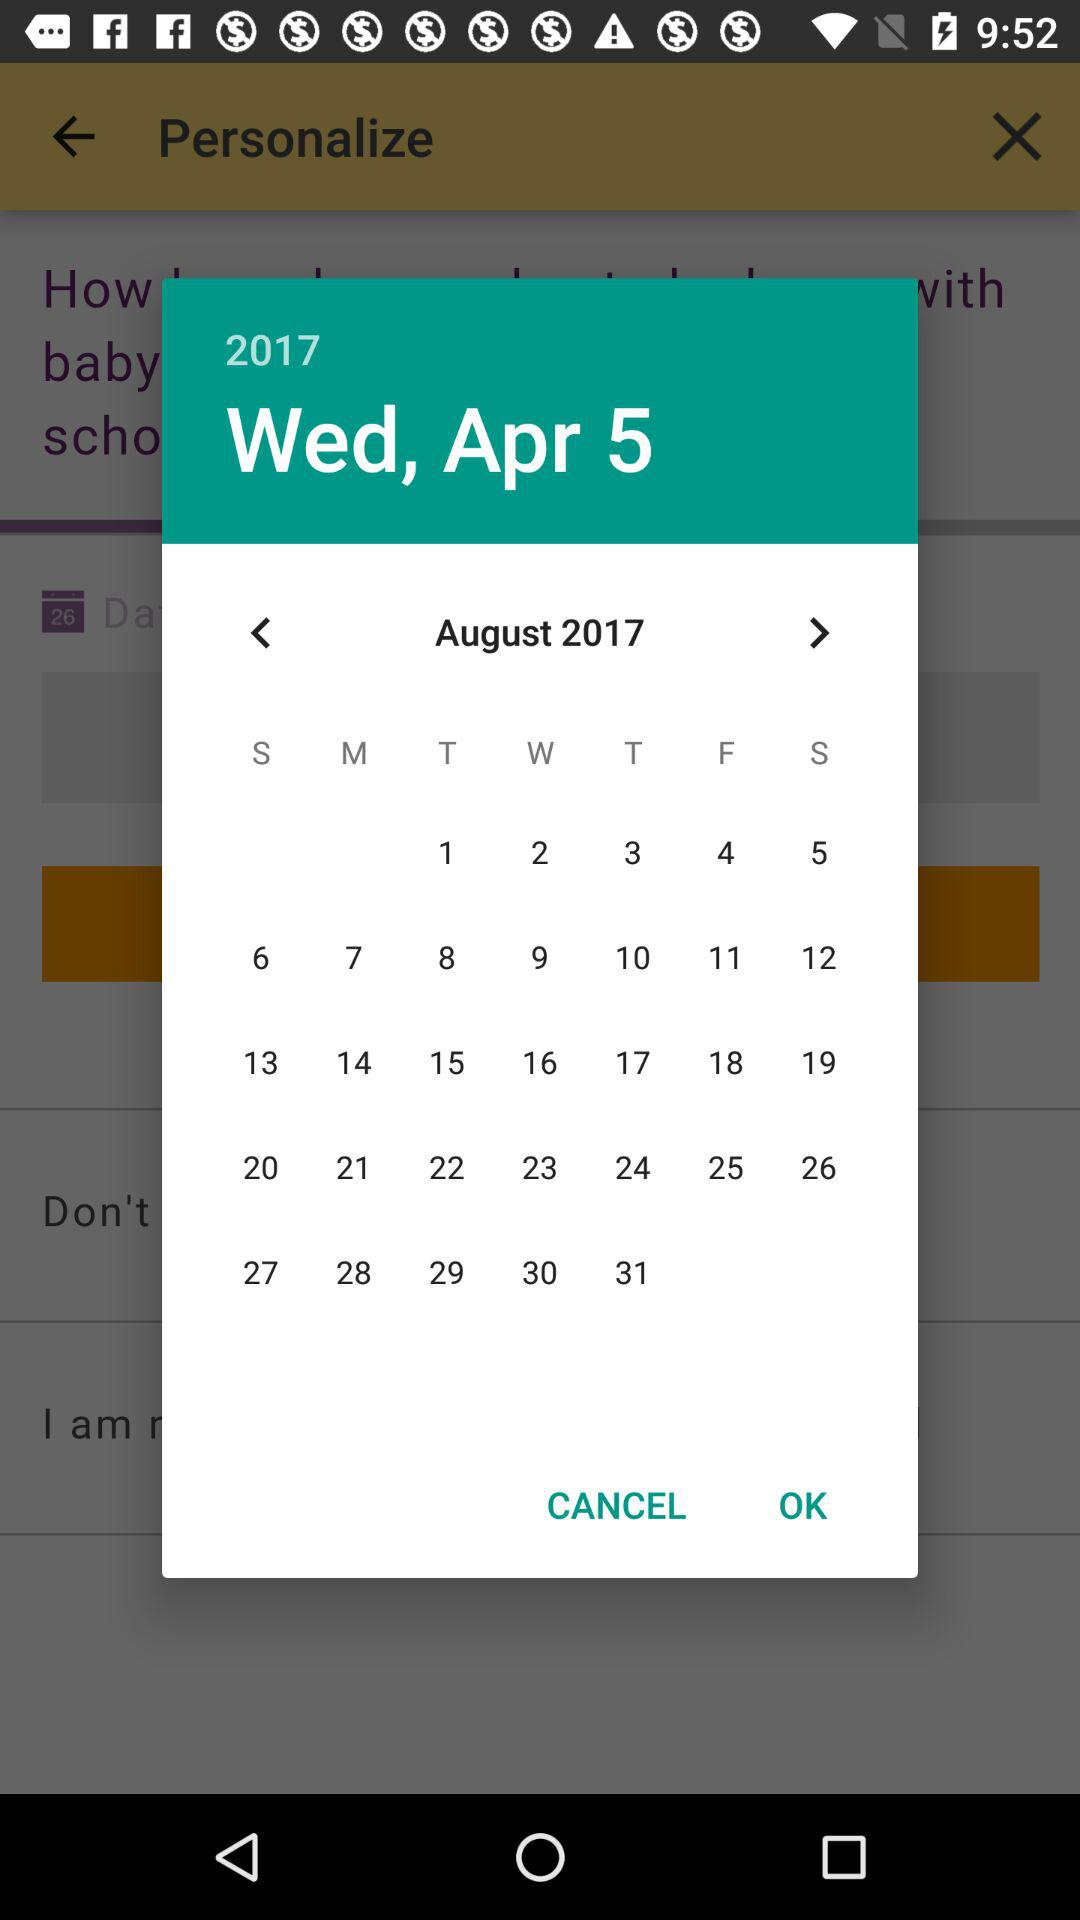What is the day on April 5? The day is Wednesday. 